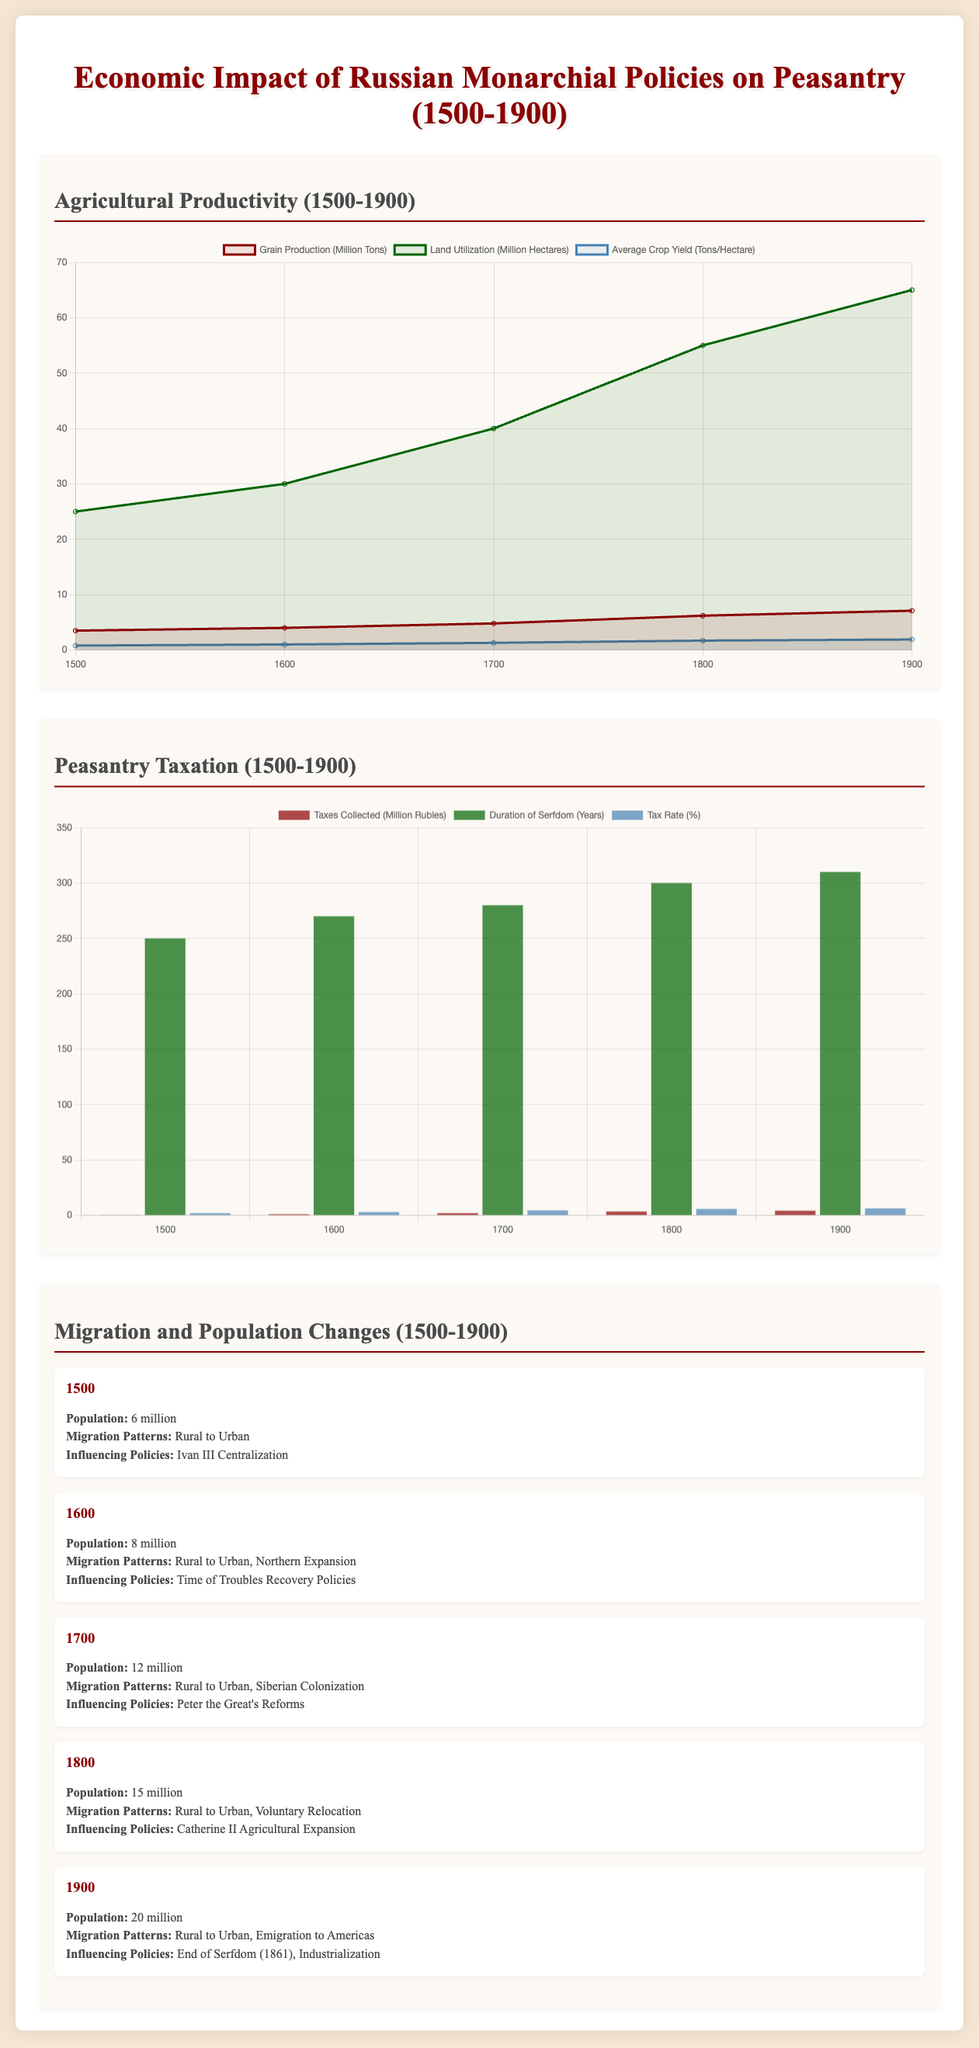What was the grain production in the year 1700? The grain production in the year 1700 is indicated in the agricultural productivity chart, which shows that it was 4.8 million tons.
Answer: 4.8 million tons What was the tax collected in 1900? The tax collected in 1900 is listed in the peasantry taxation chart as 4.2 million rubles.
Answer: 4.2 million rubles What was the population in 1800? The population in 1800 is presented in the migration and population changes flow chart, where it states that the population was 15 million.
Answer: 15 million What policy influenced Siberian colonization? The flow chart details the year 1700 where it states that Peter the Great's Reforms influenced Siberian colonization.
Answer: Peter the Great's Reforms Which year saw the highest average crop yield? The agricultural productivity chart indicates the year with the highest average crop yield was 1900 with 1.9 tons/hectare.
Answer: 1900 What was the duration of serfdom in 1600? The peasantry taxation chart provides the duration of serfdom in 1600, which is 270 years.
Answer: 270 years What migration pattern was dominant by 1900? The migration and population changes flow chart shows that by 1900, emigration to the Americas was a dominant migration pattern.
Answer: Emigration to Americas How much land was utilized in the year 1800? The agricultural productivity chart indicates that land utilization in the year 1800 was 55 million hectares.
Answer: 55 million hectares What was the tax rate in 1700? The peasantry taxation chart shows the tax rate in 1700 was 4.5 percent.
Answer: 4.5 percent 